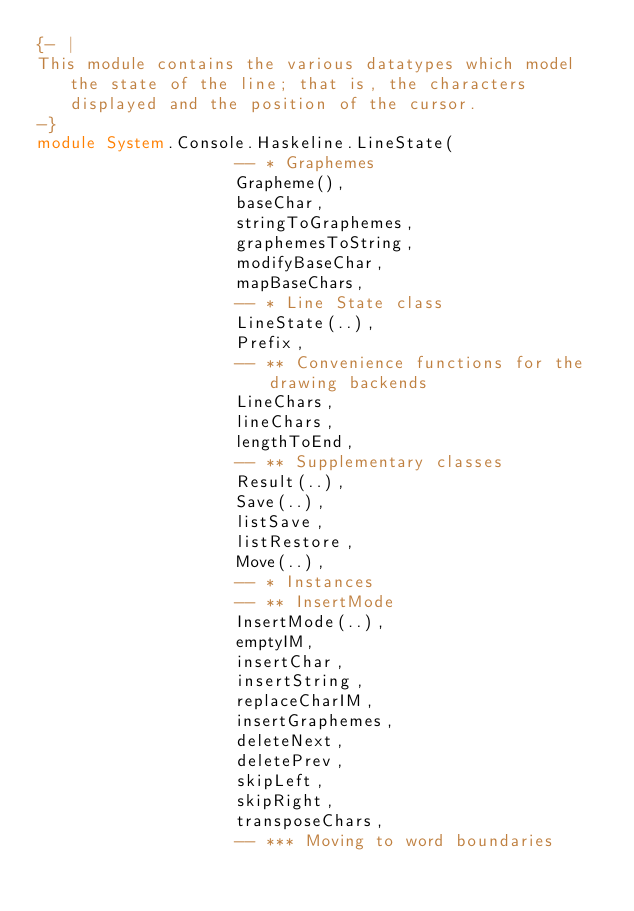<code> <loc_0><loc_0><loc_500><loc_500><_Haskell_>{- |
This module contains the various datatypes which model the state of the line; that is, the characters displayed and the position of the cursor.
-}
module System.Console.Haskeline.LineState(
                    -- * Graphemes
                    Grapheme(),
                    baseChar,
                    stringToGraphemes,
                    graphemesToString,
                    modifyBaseChar,
                    mapBaseChars,
                    -- * Line State class
                    LineState(..),
                    Prefix,
                    -- ** Convenience functions for the drawing backends
                    LineChars,
                    lineChars,
                    lengthToEnd,
                    -- ** Supplementary classes
                    Result(..),
                    Save(..),
                    listSave,
                    listRestore,
                    Move(..),
                    -- * Instances
                    -- ** InsertMode
                    InsertMode(..),
                    emptyIM,
                    insertChar,
                    insertString,
                    replaceCharIM,
                    insertGraphemes,
                    deleteNext,
                    deletePrev,
                    skipLeft,
                    skipRight,
                    transposeChars,
                    -- *** Moving to word boundaries</code> 